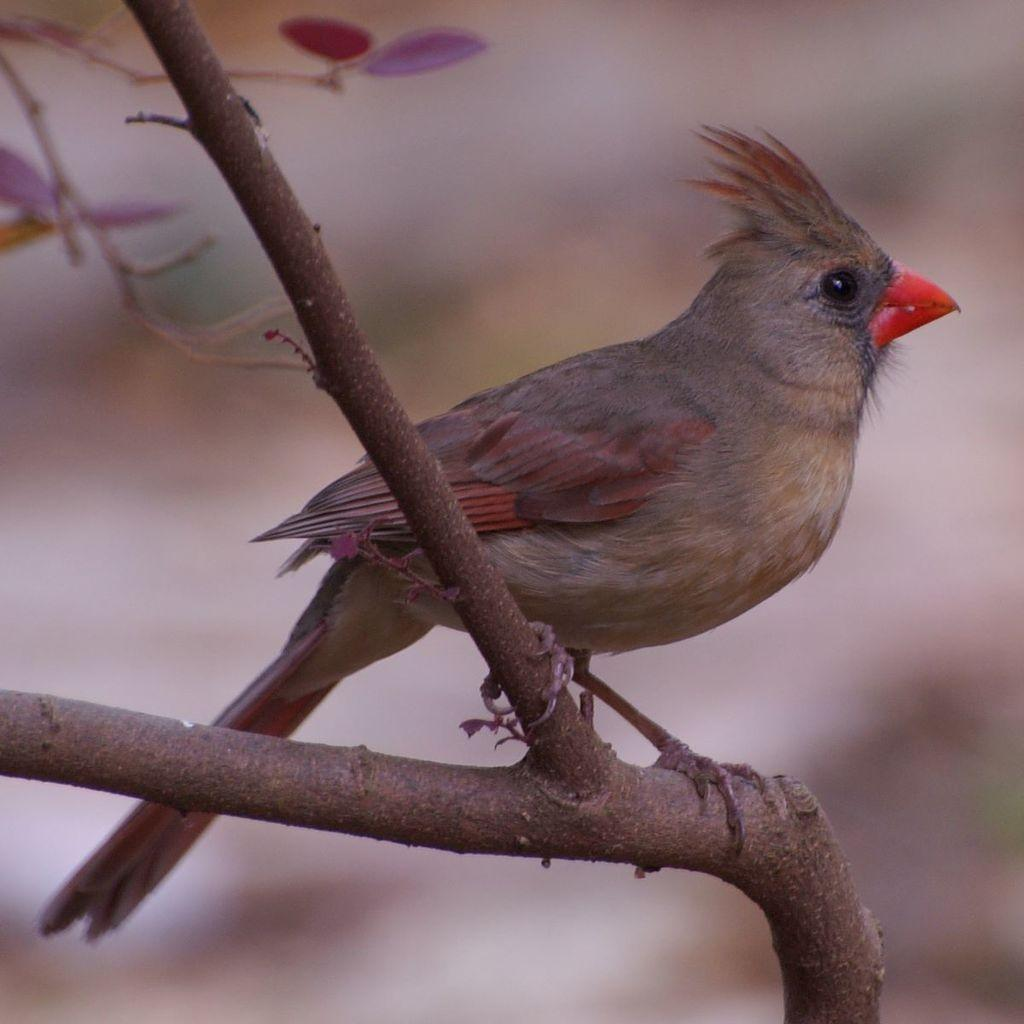What type of animal can be seen in the picture? There is a bird in the picture. Where is the bird located in the image? The bird is sitting on a branch of a tree. What color is the background behind the bird? The background of the bird is blue. What type of faucet can be seen in the picture? There is no faucet present in the picture; it features a bird sitting on a tree branch. What trick is the bird performing in the picture? The bird is not performing any tricks in the picture; it is simply sitting on a branch. 